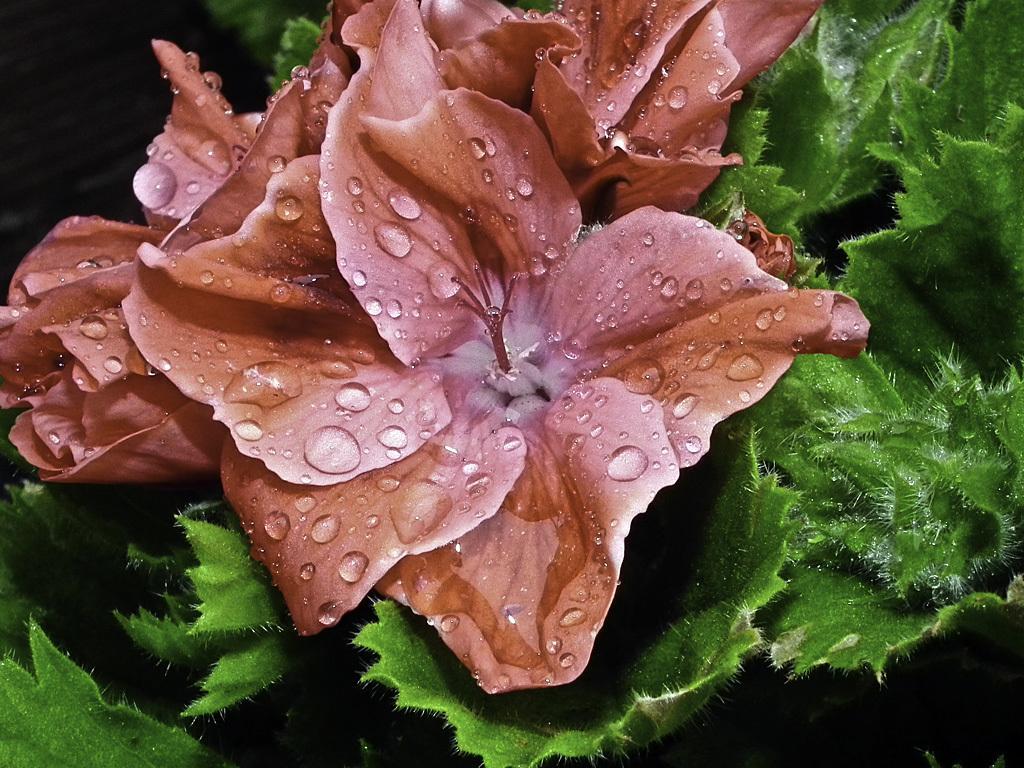Can you describe this image briefly? There is a zoom-in picture of a flower as we can see in the middle of this image, and there are some leaves in the background. 